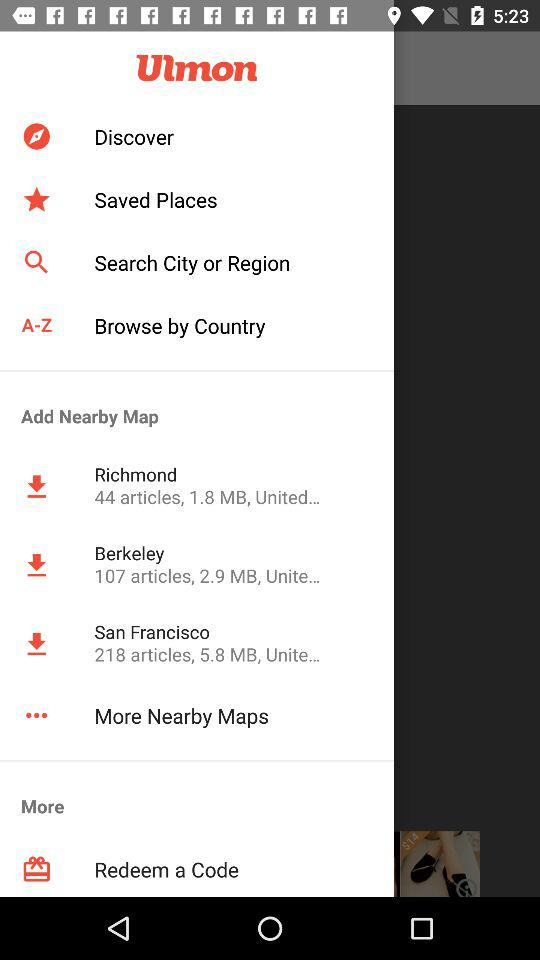How many more MB does the Berkeley map have than the Richmond map?
Answer the question using a single word or phrase. 1.1 